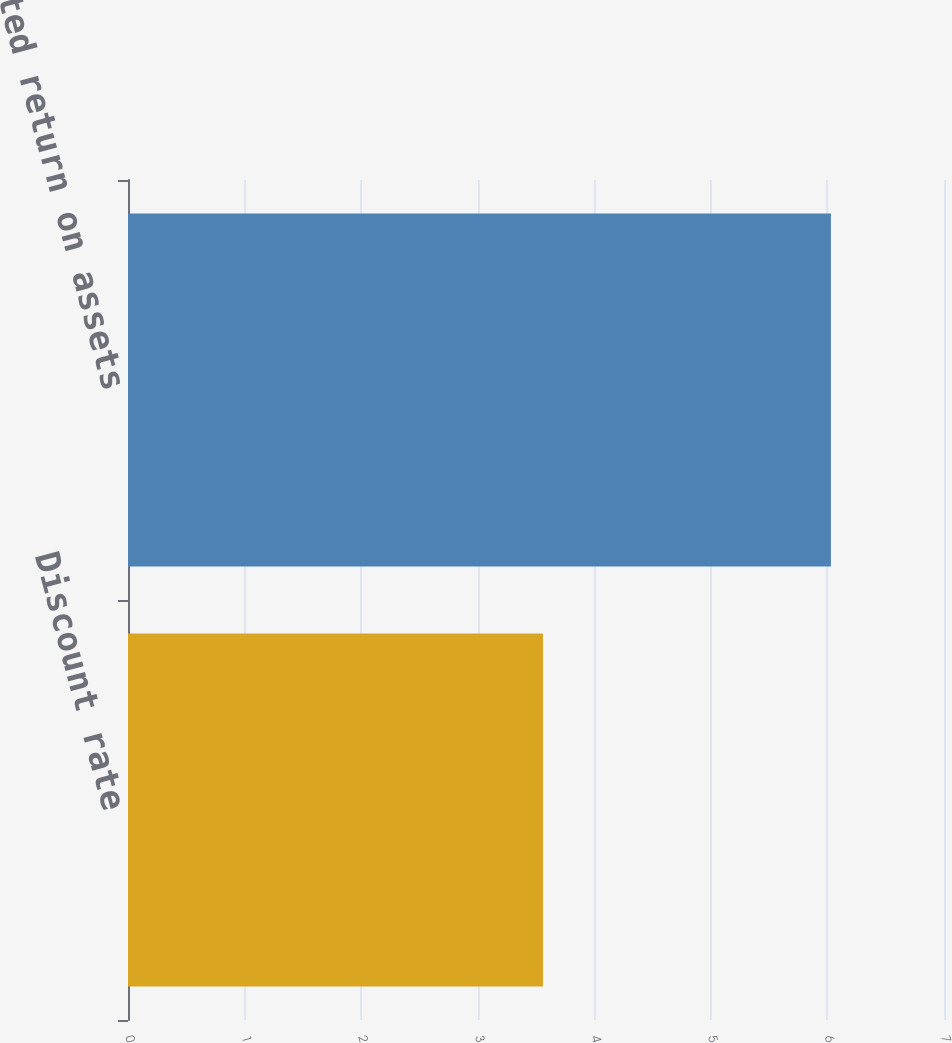Convert chart to OTSL. <chart><loc_0><loc_0><loc_500><loc_500><bar_chart><fcel>Discount rate<fcel>Expected return on assets<nl><fcel>3.56<fcel>6.03<nl></chart> 